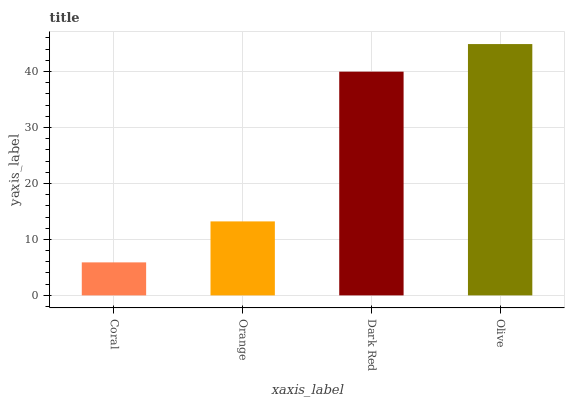Is Coral the minimum?
Answer yes or no. Yes. Is Olive the maximum?
Answer yes or no. Yes. Is Orange the minimum?
Answer yes or no. No. Is Orange the maximum?
Answer yes or no. No. Is Orange greater than Coral?
Answer yes or no. Yes. Is Coral less than Orange?
Answer yes or no. Yes. Is Coral greater than Orange?
Answer yes or no. No. Is Orange less than Coral?
Answer yes or no. No. Is Dark Red the high median?
Answer yes or no. Yes. Is Orange the low median?
Answer yes or no. Yes. Is Coral the high median?
Answer yes or no. No. Is Dark Red the low median?
Answer yes or no. No. 